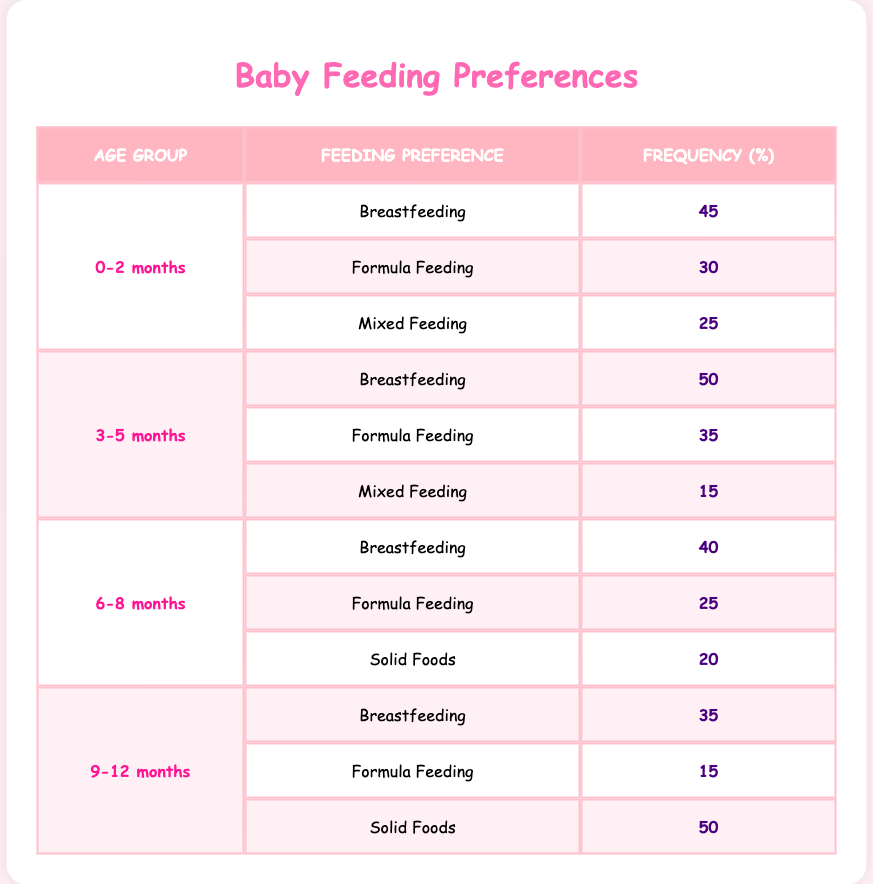What is the most common feeding preference for babies aged 0-2 months? For the age group 0-2 months, look at the feeding preferences listed. The frequency for Breastfeeding is 45, Formula Feeding is 30, and Mixed Feeding is 25. The highest frequency is for Breastfeeding.
Answer: Breastfeeding How many babies prefer Formula Feeding in the 3-5 months age group? In the 3-5 months age group, the frequency for Formula Feeding is clearly stated in the table, which is 35.
Answer: 35 What is the total frequency for Mixed Feeding across all age groups? To find the total frequency for Mixed Feeding, I need to look at the relevant rows. From the table, the frequencies are: 25 for 0-2 months, 15 for 3-5 months, and there are no Mixed Feeding preferences for 6-8 and 9-12 months. Adding these gives 25 + 15 = 40.
Answer: 40 Is Solid Foods preferred more than Breastfeeding for babies 9-12 months old? Looking at the 9-12 months age group, Breastfeeding has a frequency of 35 and Solid Foods has a frequency of 50. Since 50 is greater than 35, Solid Foods is preferred more than Breastfeeding.
Answer: Yes What is the percentage difference in preference for Breastfeeding between babies 0-2 months and 3-5 months? The frequency for Breastfeeding in the 0-2 months group is 45%, and in the 3-5 months group, it is 50%. The difference is calculated by subtracting 45 from 50, which is 5. To find the percentage difference: (5/45) * 100 = 11.11%. Therefore, there is a roughly 11.11% increase in preference for Breastfeeding from the 0-2 months to the 3-5 months age group.
Answer: 11.11% What is the total frequency for breastfeeding preferences across all age groups? To find the total breastfeeding frequency, I will sum the frequencies for all age groups: 45 (0-2 months) + 50 (3-5 months) + 40 (6-8 months) + 35 (9-12 months) = 170.
Answer: 170 